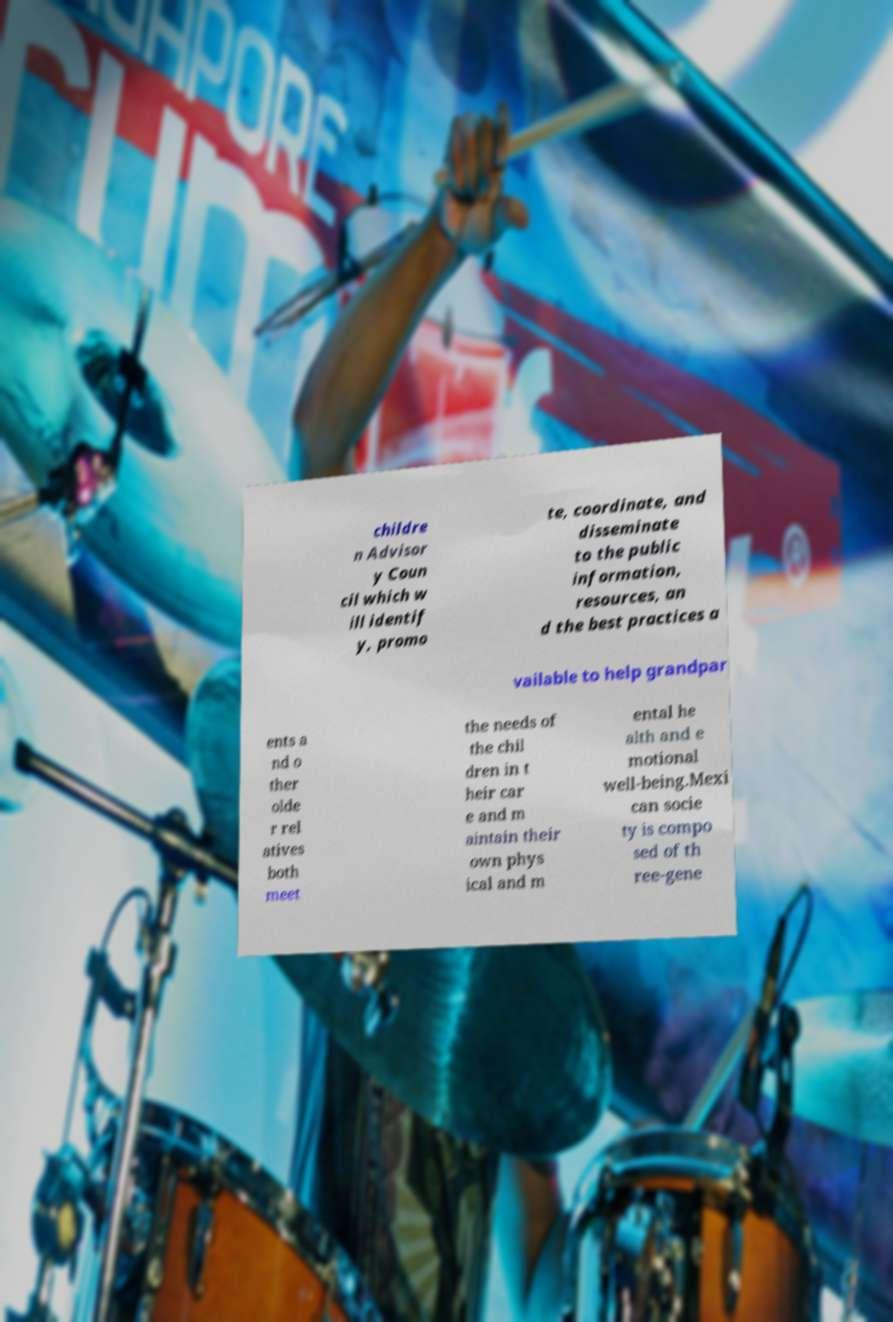Can you read and provide the text displayed in the image?This photo seems to have some interesting text. Can you extract and type it out for me? childre n Advisor y Coun cil which w ill identif y, promo te, coordinate, and disseminate to the public information, resources, an d the best practices a vailable to help grandpar ents a nd o ther olde r rel atives both meet the needs of the chil dren in t heir car e and m aintain their own phys ical and m ental he alth and e motional well-being.Mexi can socie ty is compo sed of th ree-gene 